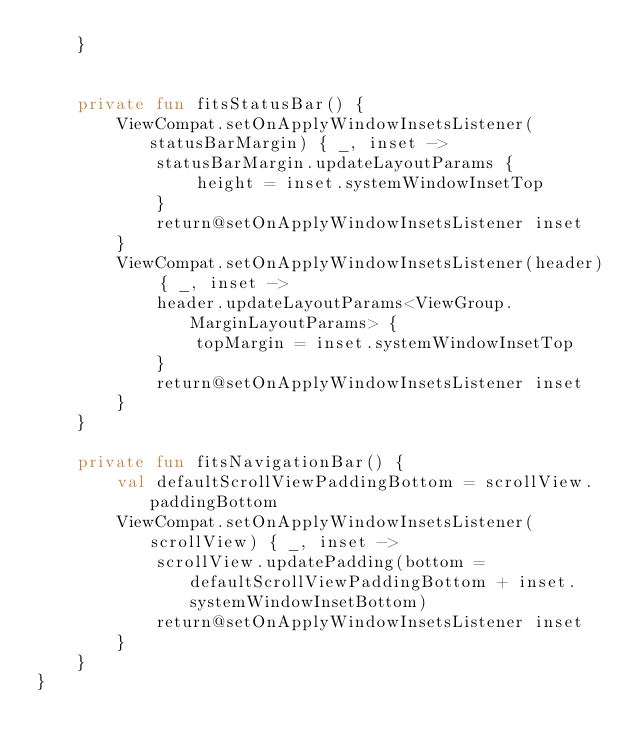Convert code to text. <code><loc_0><loc_0><loc_500><loc_500><_Kotlin_>    }


    private fun fitsStatusBar() {
        ViewCompat.setOnApplyWindowInsetsListener(statusBarMargin) { _, inset ->
            statusBarMargin.updateLayoutParams {
                height = inset.systemWindowInsetTop
            }
            return@setOnApplyWindowInsetsListener inset
        }
        ViewCompat.setOnApplyWindowInsetsListener(header) { _, inset ->
            header.updateLayoutParams<ViewGroup.MarginLayoutParams> {
                topMargin = inset.systemWindowInsetTop
            }
            return@setOnApplyWindowInsetsListener inset
        }
    }

    private fun fitsNavigationBar() {
        val defaultScrollViewPaddingBottom = scrollView.paddingBottom
        ViewCompat.setOnApplyWindowInsetsListener(scrollView) { _, inset ->
            scrollView.updatePadding(bottom = defaultScrollViewPaddingBottom + inset.systemWindowInsetBottom)
            return@setOnApplyWindowInsetsListener inset
        }
    }
}</code> 